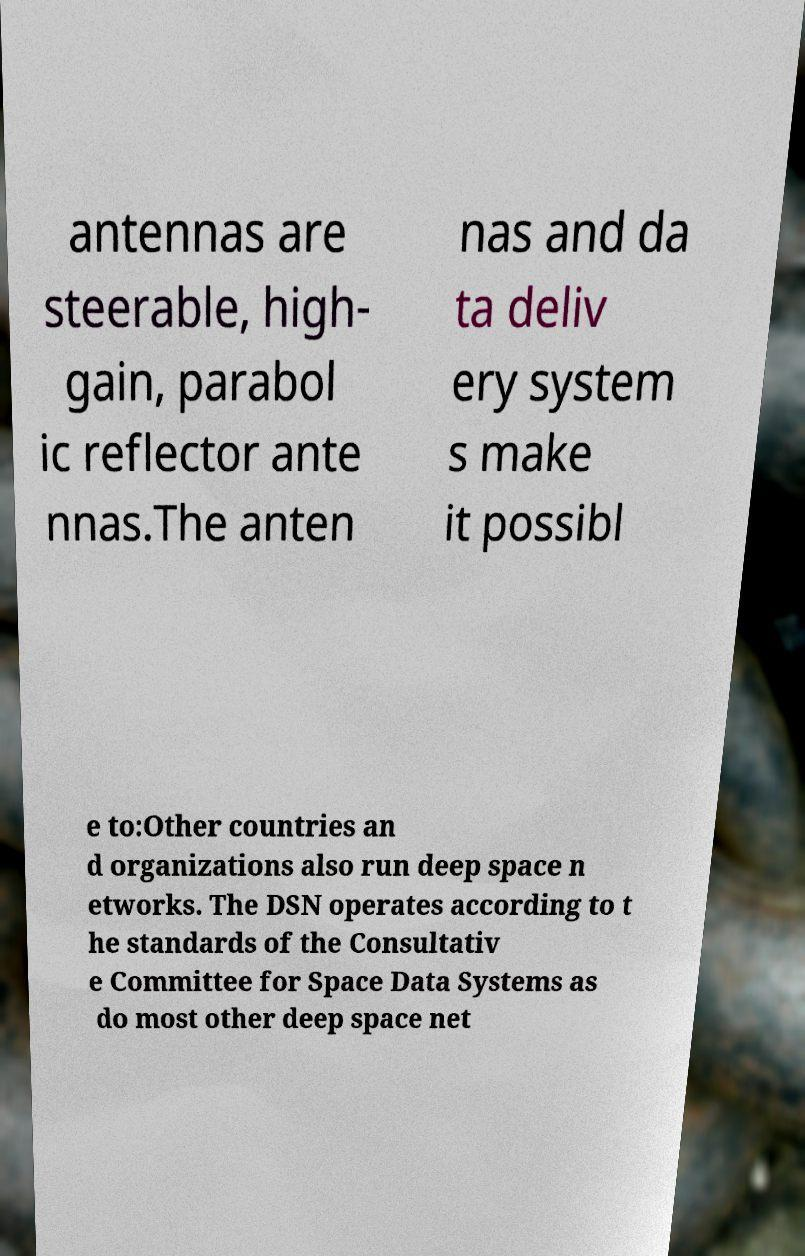There's text embedded in this image that I need extracted. Can you transcribe it verbatim? antennas are steerable, high- gain, parabol ic reflector ante nnas.The anten nas and da ta deliv ery system s make it possibl e to:Other countries an d organizations also run deep space n etworks. The DSN operates according to t he standards of the Consultativ e Committee for Space Data Systems as do most other deep space net 